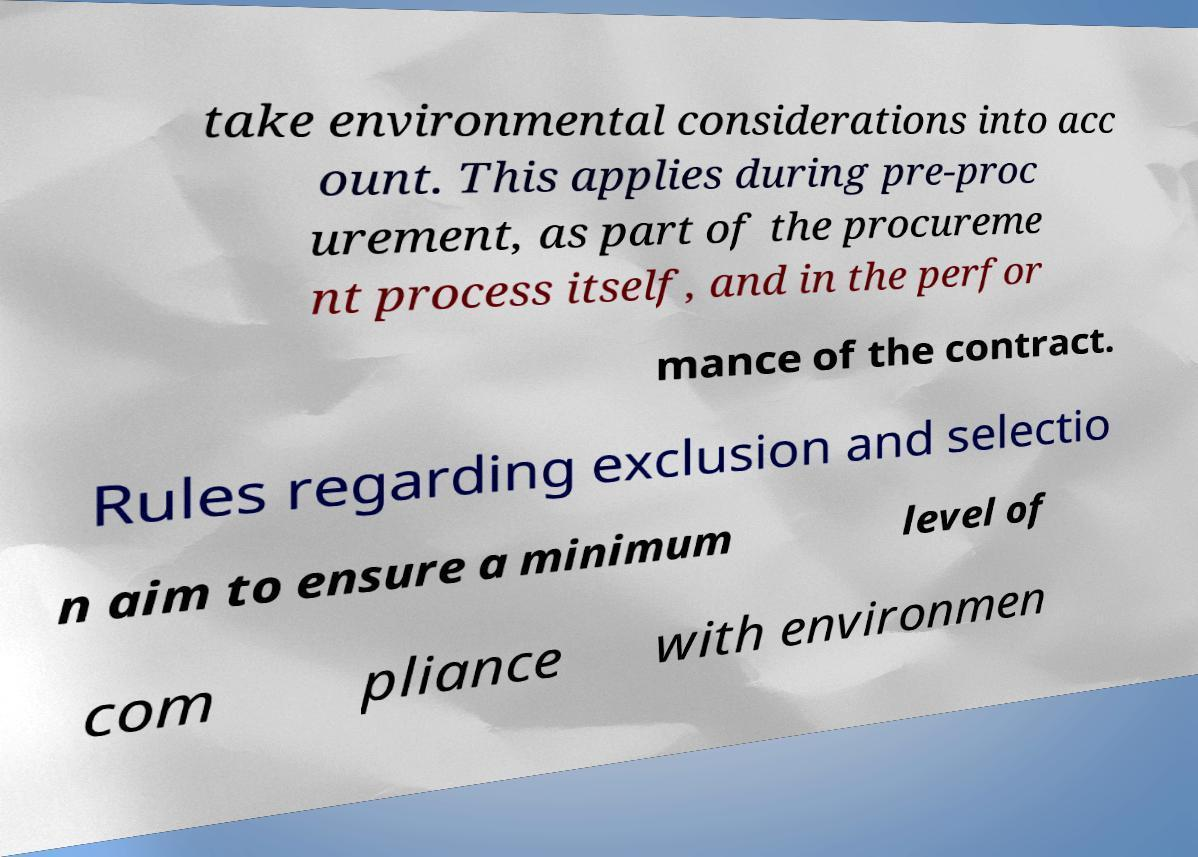There's text embedded in this image that I need extracted. Can you transcribe it verbatim? take environmental considerations into acc ount. This applies during pre-proc urement, as part of the procureme nt process itself, and in the perfor mance of the contract. Rules regarding exclusion and selectio n aim to ensure a minimum level of com pliance with environmen 